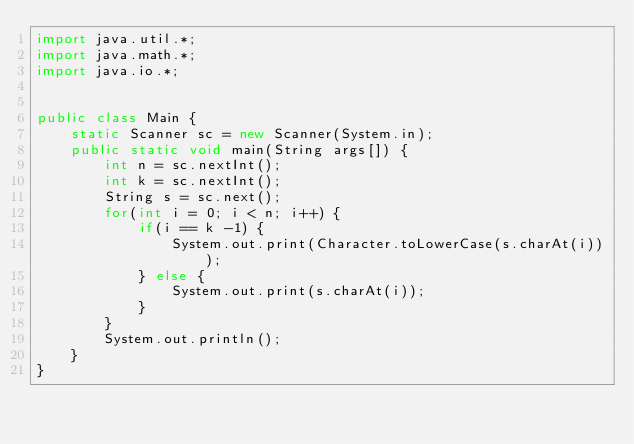Convert code to text. <code><loc_0><loc_0><loc_500><loc_500><_Java_>import java.util.*;
import java.math.*;
import java.io.*;


public class Main {
    static Scanner sc = new Scanner(System.in);
    public static void main(String args[]) {
        int n = sc.nextInt();
        int k = sc.nextInt();
        String s = sc.next();
        for(int i = 0; i < n; i++) {
            if(i == k -1) {
                System.out.print(Character.toLowerCase(s.charAt(i)));
            } else {
                System.out.print(s.charAt(i));
            }
        }
        System.out.println();
    }
}</code> 